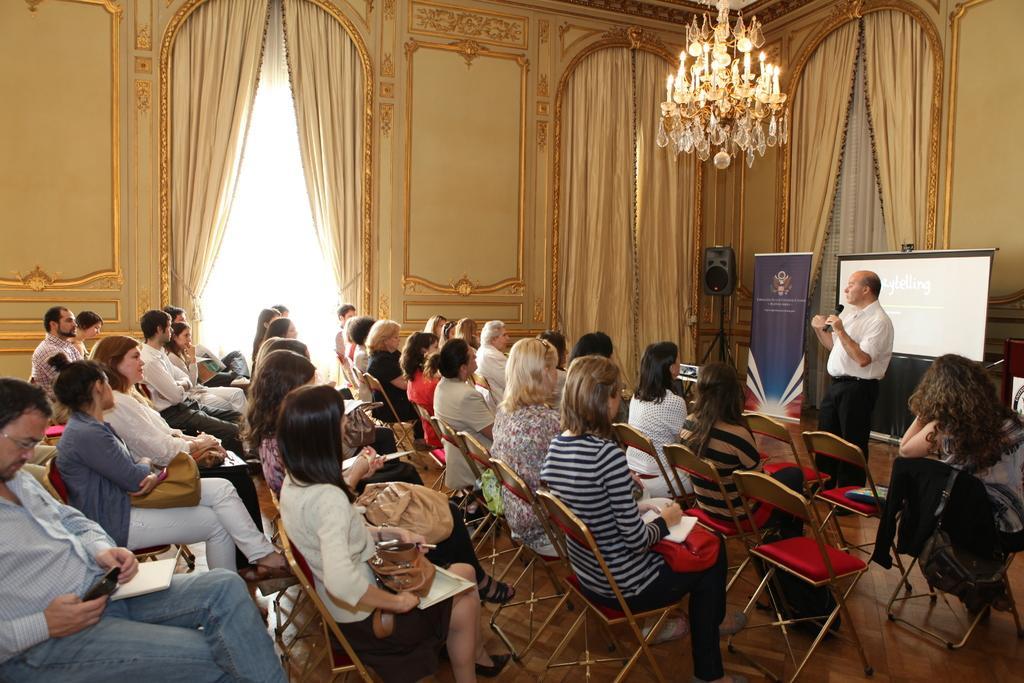Please provide a concise description of this image. In this Image I see number of people who are sitting on chairs and there is a man over here who is standing and holding a mic and I see a projector screen over. In the background I see the wall, lights and the curtains 